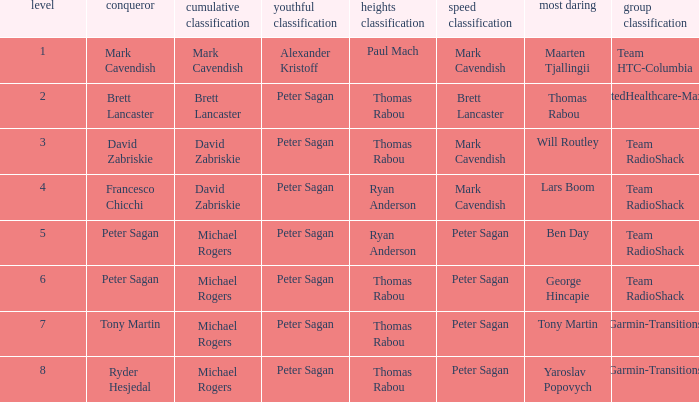Who claimed the mountains classification when maarten tjallingii secured most courageous? Paul Mach. 